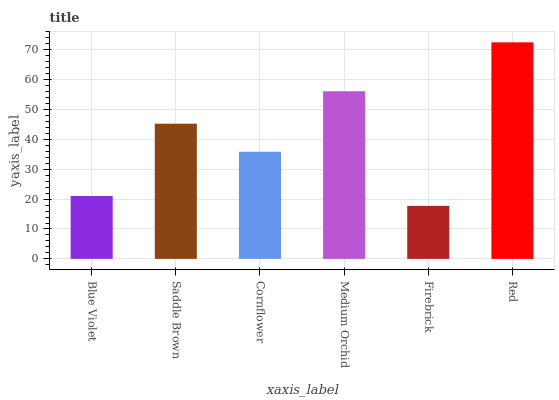Is Firebrick the minimum?
Answer yes or no. Yes. Is Red the maximum?
Answer yes or no. Yes. Is Saddle Brown the minimum?
Answer yes or no. No. Is Saddle Brown the maximum?
Answer yes or no. No. Is Saddle Brown greater than Blue Violet?
Answer yes or no. Yes. Is Blue Violet less than Saddle Brown?
Answer yes or no. Yes. Is Blue Violet greater than Saddle Brown?
Answer yes or no. No. Is Saddle Brown less than Blue Violet?
Answer yes or no. No. Is Saddle Brown the high median?
Answer yes or no. Yes. Is Cornflower the low median?
Answer yes or no. Yes. Is Firebrick the high median?
Answer yes or no. No. Is Blue Violet the low median?
Answer yes or no. No. 